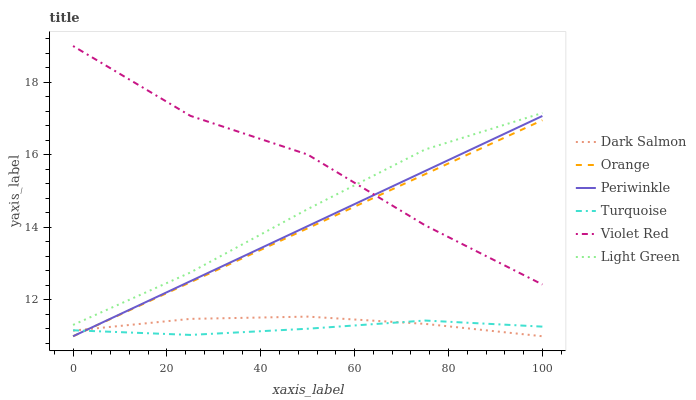Does Turquoise have the minimum area under the curve?
Answer yes or no. Yes. Does Violet Red have the maximum area under the curve?
Answer yes or no. Yes. Does Dark Salmon have the minimum area under the curve?
Answer yes or no. No. Does Dark Salmon have the maximum area under the curve?
Answer yes or no. No. Is Periwinkle the smoothest?
Answer yes or no. Yes. Is Violet Red the roughest?
Answer yes or no. Yes. Is Turquoise the smoothest?
Answer yes or no. No. Is Turquoise the roughest?
Answer yes or no. No. Does Turquoise have the lowest value?
Answer yes or no. No. Does Violet Red have the highest value?
Answer yes or no. Yes. Does Dark Salmon have the highest value?
Answer yes or no. No. Is Periwinkle less than Light Green?
Answer yes or no. Yes. Is Light Green greater than Periwinkle?
Answer yes or no. Yes. Does Periwinkle intersect Orange?
Answer yes or no. Yes. Is Periwinkle less than Orange?
Answer yes or no. No. Is Periwinkle greater than Orange?
Answer yes or no. No. Does Periwinkle intersect Light Green?
Answer yes or no. No. 